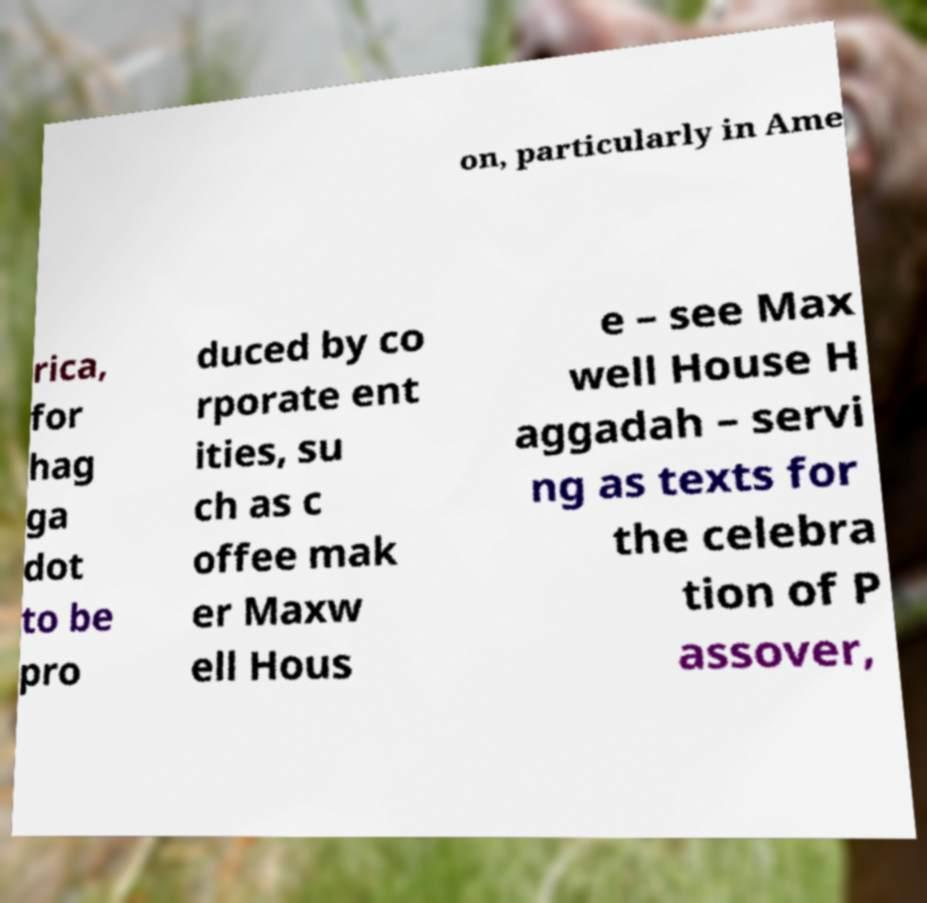What messages or text are displayed in this image? I need them in a readable, typed format. on, particularly in Ame rica, for hag ga dot to be pro duced by co rporate ent ities, su ch as c offee mak er Maxw ell Hous e – see Max well House H aggadah – servi ng as texts for the celebra tion of P assover, 